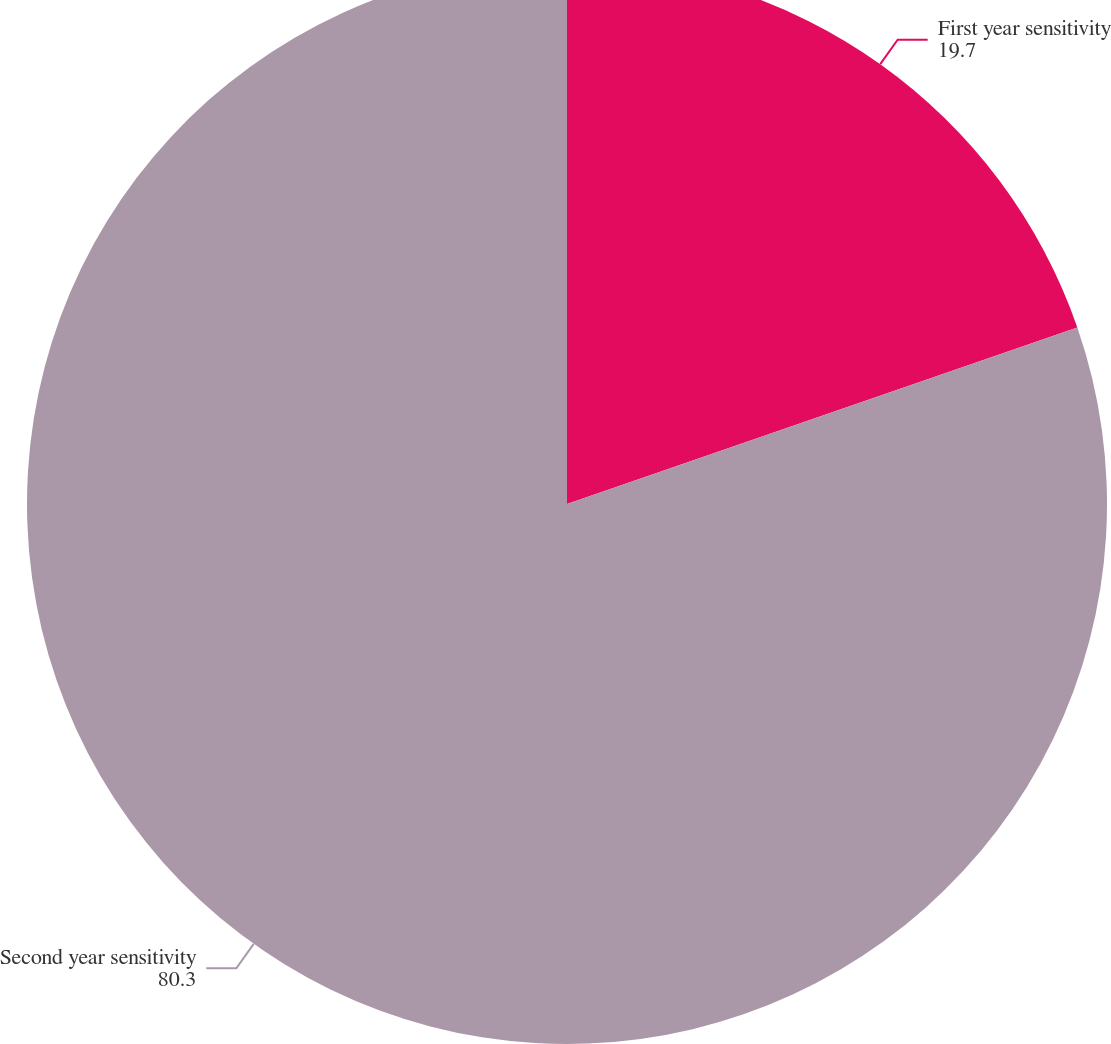Convert chart to OTSL. <chart><loc_0><loc_0><loc_500><loc_500><pie_chart><fcel>First year sensitivity<fcel>Second year sensitivity<nl><fcel>19.7%<fcel>80.3%<nl></chart> 